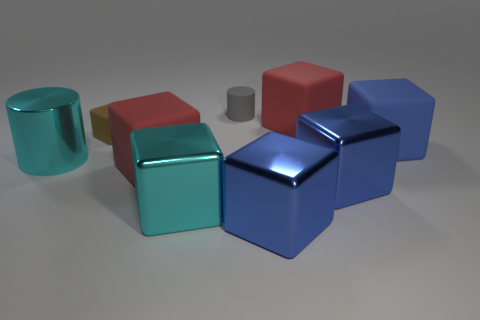How many blue cubes are there?
Your answer should be very brief. 3. There is a small thing that is left of the tiny gray cylinder; is its color the same as the cylinder to the left of the brown cube?
Keep it short and to the point. No. What is the size of the cube that is the same color as the large shiny cylinder?
Offer a very short reply. Large. How many other objects are there of the same size as the brown matte block?
Keep it short and to the point. 1. What color is the large object that is behind the tiny cube?
Your response must be concise. Red. Is the material of the red object that is behind the brown rubber cube the same as the brown cube?
Your answer should be compact. Yes. How many things are both in front of the small brown object and to the left of the cyan block?
Offer a terse response. 2. What color is the large metal cube right of the large blue block that is to the left of the red matte block right of the tiny gray rubber cylinder?
Your answer should be compact. Blue. What number of other things are there of the same shape as the gray rubber thing?
Your answer should be very brief. 1. There is a blue metallic thing in front of the cyan metal cube; are there any large red blocks that are to the left of it?
Give a very brief answer. Yes. 